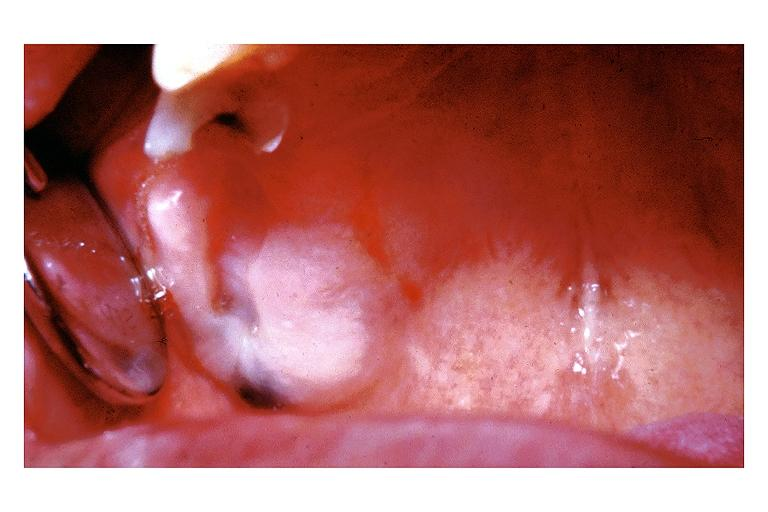where is this?
Answer the question using a single word or phrase. Oral 